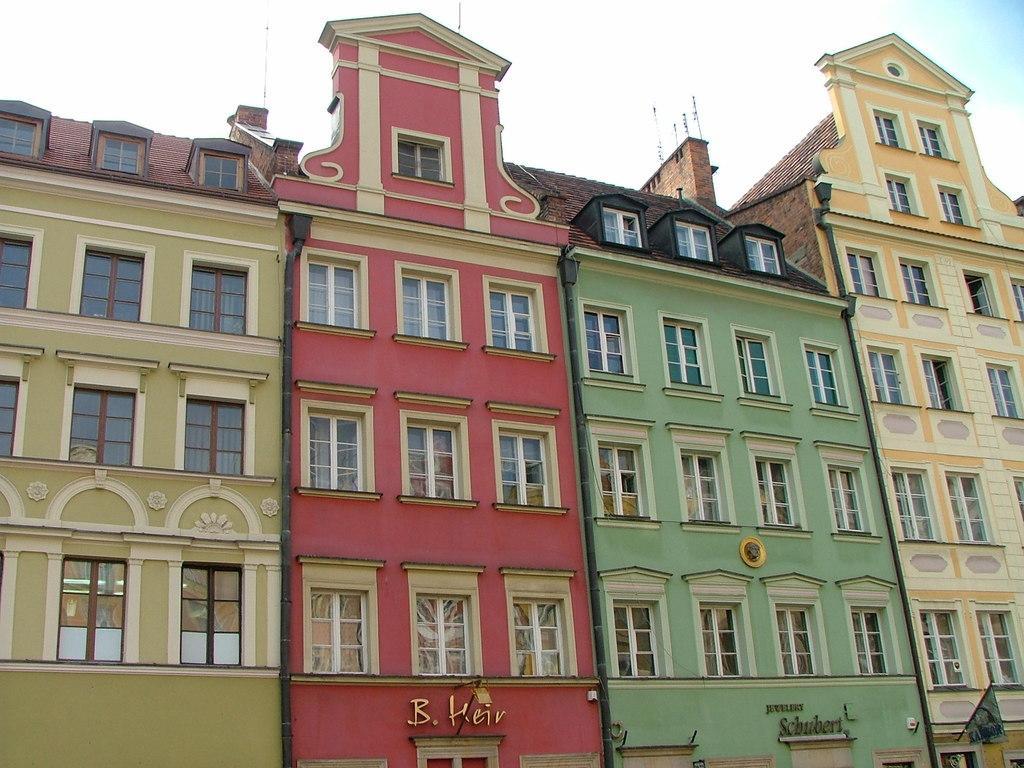In one or two sentences, can you explain what this image depicts? In this picture we can see buildings with windows and pipes. At the bottom of the image, there are name boards and a flag. At the top of the image, there is the sky. 